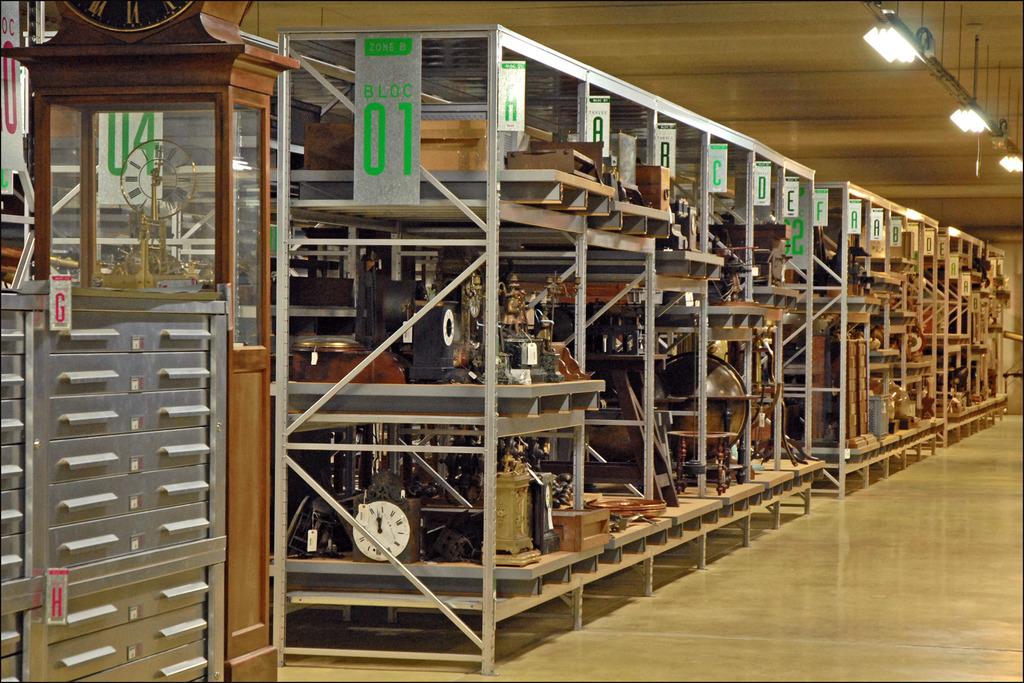What number is written in green at the very left?
Ensure brevity in your answer.  01. 